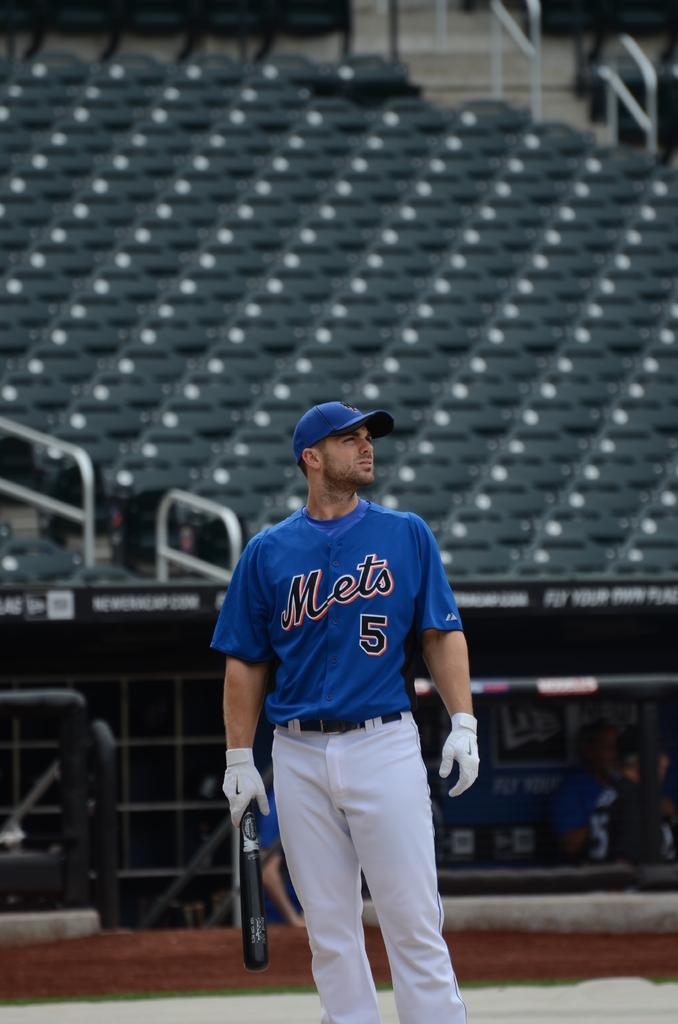<image>
Render a clear and concise summary of the photo. Mets baseball player that is looking into the outfield, he is #5. 